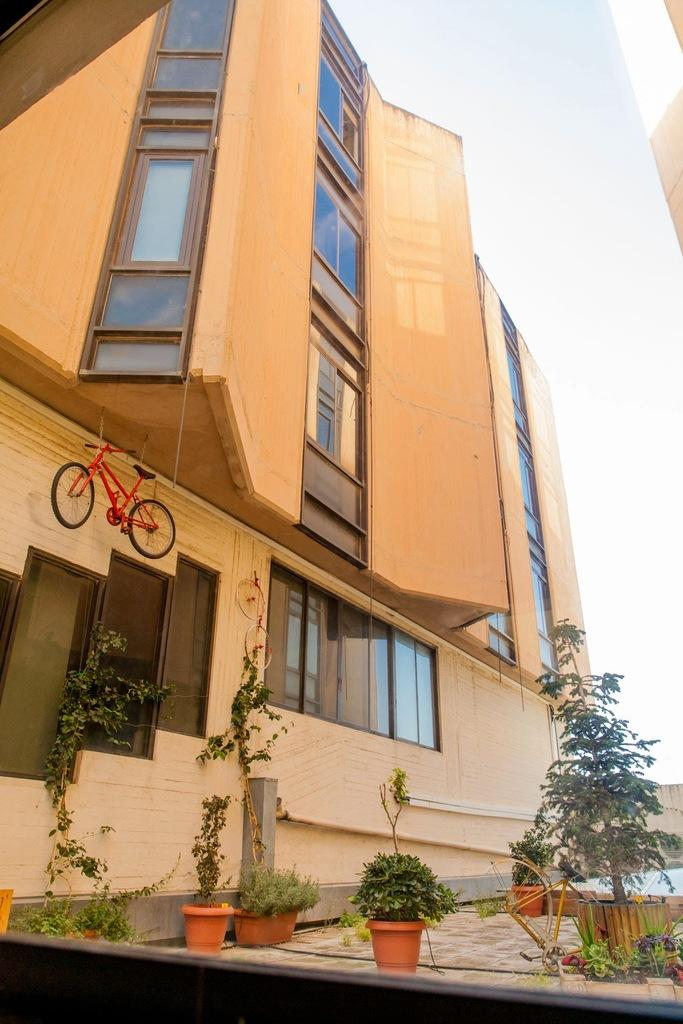What type of structure is present in the image? There is a building in the image. What can be seen near the building? There is a bicycle in the image. What features can be observed on the building? The building has windows. What type of vegetation is present in the image? There are trees and plants in the image. What is visible in the background of the image? The sky is visible in the image. How many thumbs can be seen respecting the limit in the image? There are no thumbs or limits present in the image. 